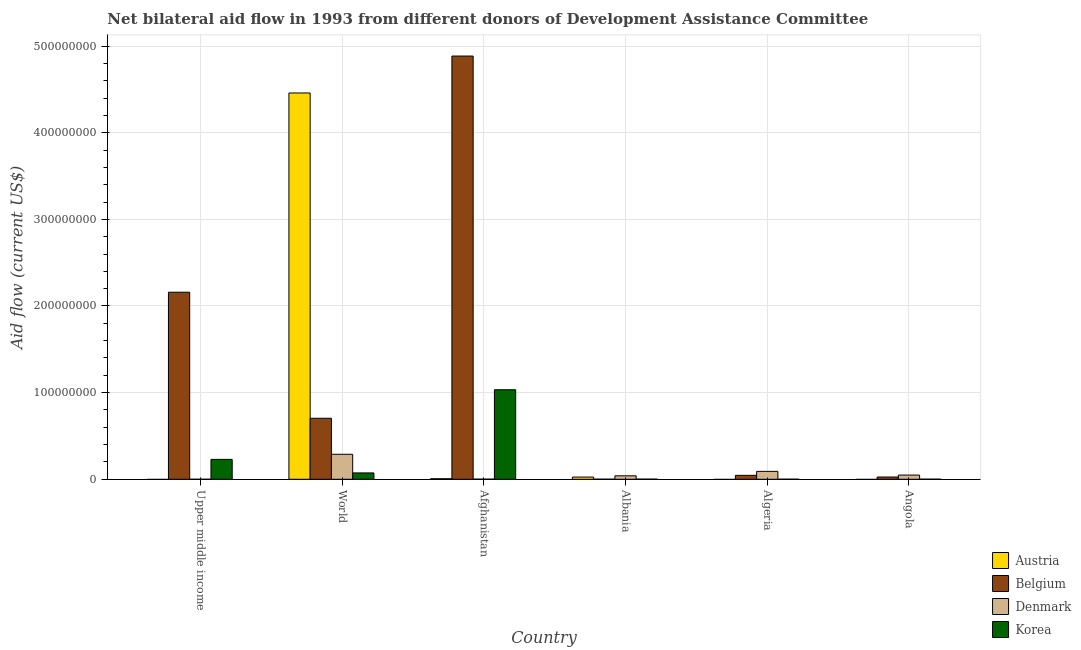How many different coloured bars are there?
Offer a terse response. 4. How many groups of bars are there?
Your answer should be compact. 6. Are the number of bars per tick equal to the number of legend labels?
Make the answer very short. No. Are the number of bars on each tick of the X-axis equal?
Give a very brief answer. No. What is the label of the 3rd group of bars from the left?
Offer a terse response. Afghanistan. In how many cases, is the number of bars for a given country not equal to the number of legend labels?
Offer a terse response. 3. What is the amount of aid given by korea in Albania?
Offer a terse response. 1.40e+05. Across all countries, what is the maximum amount of aid given by austria?
Give a very brief answer. 4.46e+08. Across all countries, what is the minimum amount of aid given by korea?
Ensure brevity in your answer.  7.00e+04. In which country was the amount of aid given by belgium maximum?
Keep it short and to the point. Afghanistan. What is the total amount of aid given by denmark in the graph?
Offer a terse response. 4.69e+07. What is the difference between the amount of aid given by korea in Algeria and that in Angola?
Provide a short and direct response. -4.00e+04. What is the difference between the amount of aid given by belgium in Upper middle income and the amount of aid given by korea in World?
Your response must be concise. 2.09e+08. What is the average amount of aid given by denmark per country?
Offer a very short reply. 7.82e+06. What is the difference between the amount of aid given by denmark and amount of aid given by austria in World?
Ensure brevity in your answer.  -4.17e+08. In how many countries, is the amount of aid given by denmark greater than 160000000 US$?
Your answer should be very brief. 0. What is the ratio of the amount of aid given by belgium in Albania to that in World?
Your answer should be compact. 0. Is the amount of aid given by belgium in Afghanistan less than that in Upper middle income?
Your answer should be very brief. No. What is the difference between the highest and the second highest amount of aid given by belgium?
Provide a short and direct response. 2.73e+08. What is the difference between the highest and the lowest amount of aid given by denmark?
Offer a very short reply. 2.88e+07. In how many countries, is the amount of aid given by austria greater than the average amount of aid given by austria taken over all countries?
Provide a succinct answer. 1. Is it the case that in every country, the sum of the amount of aid given by denmark and amount of aid given by austria is greater than the sum of amount of aid given by korea and amount of aid given by belgium?
Your answer should be compact. Yes. How many bars are there?
Make the answer very short. 21. How many countries are there in the graph?
Provide a succinct answer. 6. Does the graph contain any zero values?
Give a very brief answer. Yes. Does the graph contain grids?
Provide a succinct answer. Yes. Where does the legend appear in the graph?
Provide a succinct answer. Bottom right. How are the legend labels stacked?
Ensure brevity in your answer.  Vertical. What is the title of the graph?
Ensure brevity in your answer.  Net bilateral aid flow in 1993 from different donors of Development Assistance Committee. What is the Aid flow (current US$) in Austria in Upper middle income?
Ensure brevity in your answer.  0. What is the Aid flow (current US$) in Belgium in Upper middle income?
Your answer should be compact. 2.16e+08. What is the Aid flow (current US$) in Korea in Upper middle income?
Ensure brevity in your answer.  2.30e+07. What is the Aid flow (current US$) in Austria in World?
Provide a succinct answer. 4.46e+08. What is the Aid flow (current US$) of Belgium in World?
Offer a terse response. 7.04e+07. What is the Aid flow (current US$) of Denmark in World?
Make the answer very short. 2.88e+07. What is the Aid flow (current US$) in Korea in World?
Make the answer very short. 7.34e+06. What is the Aid flow (current US$) in Austria in Afghanistan?
Your answer should be compact. 6.50e+05. What is the Aid flow (current US$) in Belgium in Afghanistan?
Offer a terse response. 4.88e+08. What is the Aid flow (current US$) of Korea in Afghanistan?
Make the answer very short. 1.03e+08. What is the Aid flow (current US$) of Austria in Albania?
Offer a terse response. 2.54e+06. What is the Aid flow (current US$) in Korea in Albania?
Provide a short and direct response. 1.40e+05. What is the Aid flow (current US$) of Austria in Algeria?
Keep it short and to the point. 0. What is the Aid flow (current US$) of Belgium in Algeria?
Keep it short and to the point. 4.55e+06. What is the Aid flow (current US$) of Denmark in Algeria?
Offer a very short reply. 9.12e+06. What is the Aid flow (current US$) in Belgium in Angola?
Provide a short and direct response. 2.59e+06. What is the Aid flow (current US$) of Denmark in Angola?
Your answer should be very brief. 4.85e+06. What is the Aid flow (current US$) of Korea in Angola?
Your answer should be compact. 1.10e+05. Across all countries, what is the maximum Aid flow (current US$) in Austria?
Provide a short and direct response. 4.46e+08. Across all countries, what is the maximum Aid flow (current US$) in Belgium?
Offer a terse response. 4.88e+08. Across all countries, what is the maximum Aid flow (current US$) in Denmark?
Your response must be concise. 2.88e+07. Across all countries, what is the maximum Aid flow (current US$) in Korea?
Your answer should be compact. 1.03e+08. Across all countries, what is the minimum Aid flow (current US$) of Belgium?
Offer a terse response. 1.00e+05. Across all countries, what is the minimum Aid flow (current US$) of Korea?
Your answer should be very brief. 7.00e+04. What is the total Aid flow (current US$) in Austria in the graph?
Your response must be concise. 4.49e+08. What is the total Aid flow (current US$) in Belgium in the graph?
Offer a very short reply. 7.82e+08. What is the total Aid flow (current US$) of Denmark in the graph?
Your answer should be very brief. 4.69e+07. What is the total Aid flow (current US$) of Korea in the graph?
Ensure brevity in your answer.  1.34e+08. What is the difference between the Aid flow (current US$) in Belgium in Upper middle income and that in World?
Offer a very short reply. 1.45e+08. What is the difference between the Aid flow (current US$) in Denmark in Upper middle income and that in World?
Keep it short and to the point. -2.88e+07. What is the difference between the Aid flow (current US$) in Korea in Upper middle income and that in World?
Your answer should be compact. 1.56e+07. What is the difference between the Aid flow (current US$) in Belgium in Upper middle income and that in Afghanistan?
Make the answer very short. -2.73e+08. What is the difference between the Aid flow (current US$) in Korea in Upper middle income and that in Afghanistan?
Provide a short and direct response. -8.04e+07. What is the difference between the Aid flow (current US$) of Belgium in Upper middle income and that in Albania?
Provide a short and direct response. 2.16e+08. What is the difference between the Aid flow (current US$) of Denmark in Upper middle income and that in Albania?
Your answer should be very brief. -3.99e+06. What is the difference between the Aid flow (current US$) in Korea in Upper middle income and that in Albania?
Your response must be concise. 2.28e+07. What is the difference between the Aid flow (current US$) of Belgium in Upper middle income and that in Algeria?
Give a very brief answer. 2.11e+08. What is the difference between the Aid flow (current US$) of Denmark in Upper middle income and that in Algeria?
Offer a very short reply. -9.11e+06. What is the difference between the Aid flow (current US$) in Korea in Upper middle income and that in Algeria?
Your answer should be very brief. 2.29e+07. What is the difference between the Aid flow (current US$) of Belgium in Upper middle income and that in Angola?
Offer a very short reply. 2.13e+08. What is the difference between the Aid flow (current US$) in Denmark in Upper middle income and that in Angola?
Provide a short and direct response. -4.84e+06. What is the difference between the Aid flow (current US$) of Korea in Upper middle income and that in Angola?
Make the answer very short. 2.28e+07. What is the difference between the Aid flow (current US$) in Austria in World and that in Afghanistan?
Provide a succinct answer. 4.45e+08. What is the difference between the Aid flow (current US$) in Belgium in World and that in Afghanistan?
Provide a short and direct response. -4.18e+08. What is the difference between the Aid flow (current US$) of Denmark in World and that in Afghanistan?
Provide a short and direct response. 2.87e+07. What is the difference between the Aid flow (current US$) in Korea in World and that in Afghanistan?
Keep it short and to the point. -9.60e+07. What is the difference between the Aid flow (current US$) in Austria in World and that in Albania?
Your response must be concise. 4.43e+08. What is the difference between the Aid flow (current US$) of Belgium in World and that in Albania?
Offer a terse response. 7.03e+07. What is the difference between the Aid flow (current US$) of Denmark in World and that in Albania?
Give a very brief answer. 2.48e+07. What is the difference between the Aid flow (current US$) of Korea in World and that in Albania?
Your answer should be very brief. 7.20e+06. What is the difference between the Aid flow (current US$) of Belgium in World and that in Algeria?
Offer a terse response. 6.59e+07. What is the difference between the Aid flow (current US$) in Denmark in World and that in Algeria?
Your answer should be very brief. 1.97e+07. What is the difference between the Aid flow (current US$) of Korea in World and that in Algeria?
Ensure brevity in your answer.  7.27e+06. What is the difference between the Aid flow (current US$) of Belgium in World and that in Angola?
Offer a very short reply. 6.78e+07. What is the difference between the Aid flow (current US$) of Denmark in World and that in Angola?
Your response must be concise. 2.40e+07. What is the difference between the Aid flow (current US$) in Korea in World and that in Angola?
Your response must be concise. 7.23e+06. What is the difference between the Aid flow (current US$) of Austria in Afghanistan and that in Albania?
Offer a very short reply. -1.89e+06. What is the difference between the Aid flow (current US$) of Belgium in Afghanistan and that in Albania?
Ensure brevity in your answer.  4.88e+08. What is the difference between the Aid flow (current US$) in Denmark in Afghanistan and that in Albania?
Your answer should be very brief. -3.89e+06. What is the difference between the Aid flow (current US$) of Korea in Afghanistan and that in Albania?
Your answer should be very brief. 1.03e+08. What is the difference between the Aid flow (current US$) of Belgium in Afghanistan and that in Algeria?
Make the answer very short. 4.84e+08. What is the difference between the Aid flow (current US$) of Denmark in Afghanistan and that in Algeria?
Ensure brevity in your answer.  -9.01e+06. What is the difference between the Aid flow (current US$) of Korea in Afghanistan and that in Algeria?
Provide a short and direct response. 1.03e+08. What is the difference between the Aid flow (current US$) in Belgium in Afghanistan and that in Angola?
Ensure brevity in your answer.  4.86e+08. What is the difference between the Aid flow (current US$) in Denmark in Afghanistan and that in Angola?
Ensure brevity in your answer.  -4.74e+06. What is the difference between the Aid flow (current US$) of Korea in Afghanistan and that in Angola?
Your answer should be compact. 1.03e+08. What is the difference between the Aid flow (current US$) of Belgium in Albania and that in Algeria?
Offer a terse response. -4.45e+06. What is the difference between the Aid flow (current US$) in Denmark in Albania and that in Algeria?
Offer a terse response. -5.12e+06. What is the difference between the Aid flow (current US$) in Korea in Albania and that in Algeria?
Your answer should be very brief. 7.00e+04. What is the difference between the Aid flow (current US$) in Belgium in Albania and that in Angola?
Offer a terse response. -2.49e+06. What is the difference between the Aid flow (current US$) of Denmark in Albania and that in Angola?
Your response must be concise. -8.50e+05. What is the difference between the Aid flow (current US$) in Korea in Albania and that in Angola?
Provide a short and direct response. 3.00e+04. What is the difference between the Aid flow (current US$) in Belgium in Algeria and that in Angola?
Ensure brevity in your answer.  1.96e+06. What is the difference between the Aid flow (current US$) in Denmark in Algeria and that in Angola?
Make the answer very short. 4.27e+06. What is the difference between the Aid flow (current US$) of Korea in Algeria and that in Angola?
Keep it short and to the point. -4.00e+04. What is the difference between the Aid flow (current US$) in Belgium in Upper middle income and the Aid flow (current US$) in Denmark in World?
Keep it short and to the point. 1.87e+08. What is the difference between the Aid flow (current US$) of Belgium in Upper middle income and the Aid flow (current US$) of Korea in World?
Provide a short and direct response. 2.09e+08. What is the difference between the Aid flow (current US$) in Denmark in Upper middle income and the Aid flow (current US$) in Korea in World?
Provide a succinct answer. -7.33e+06. What is the difference between the Aid flow (current US$) in Belgium in Upper middle income and the Aid flow (current US$) in Denmark in Afghanistan?
Offer a very short reply. 2.16e+08. What is the difference between the Aid flow (current US$) of Belgium in Upper middle income and the Aid flow (current US$) of Korea in Afghanistan?
Offer a terse response. 1.13e+08. What is the difference between the Aid flow (current US$) in Denmark in Upper middle income and the Aid flow (current US$) in Korea in Afghanistan?
Give a very brief answer. -1.03e+08. What is the difference between the Aid flow (current US$) in Belgium in Upper middle income and the Aid flow (current US$) in Denmark in Albania?
Offer a very short reply. 2.12e+08. What is the difference between the Aid flow (current US$) in Belgium in Upper middle income and the Aid flow (current US$) in Korea in Albania?
Make the answer very short. 2.16e+08. What is the difference between the Aid flow (current US$) in Denmark in Upper middle income and the Aid flow (current US$) in Korea in Albania?
Keep it short and to the point. -1.30e+05. What is the difference between the Aid flow (current US$) of Belgium in Upper middle income and the Aid flow (current US$) of Denmark in Algeria?
Provide a succinct answer. 2.07e+08. What is the difference between the Aid flow (current US$) of Belgium in Upper middle income and the Aid flow (current US$) of Korea in Algeria?
Keep it short and to the point. 2.16e+08. What is the difference between the Aid flow (current US$) in Denmark in Upper middle income and the Aid flow (current US$) in Korea in Algeria?
Make the answer very short. -6.00e+04. What is the difference between the Aid flow (current US$) of Belgium in Upper middle income and the Aid flow (current US$) of Denmark in Angola?
Offer a terse response. 2.11e+08. What is the difference between the Aid flow (current US$) in Belgium in Upper middle income and the Aid flow (current US$) in Korea in Angola?
Offer a terse response. 2.16e+08. What is the difference between the Aid flow (current US$) in Denmark in Upper middle income and the Aid flow (current US$) in Korea in Angola?
Offer a terse response. -1.00e+05. What is the difference between the Aid flow (current US$) of Austria in World and the Aid flow (current US$) of Belgium in Afghanistan?
Your response must be concise. -4.26e+07. What is the difference between the Aid flow (current US$) of Austria in World and the Aid flow (current US$) of Denmark in Afghanistan?
Your response must be concise. 4.46e+08. What is the difference between the Aid flow (current US$) of Austria in World and the Aid flow (current US$) of Korea in Afghanistan?
Keep it short and to the point. 3.43e+08. What is the difference between the Aid flow (current US$) in Belgium in World and the Aid flow (current US$) in Denmark in Afghanistan?
Your answer should be compact. 7.03e+07. What is the difference between the Aid flow (current US$) of Belgium in World and the Aid flow (current US$) of Korea in Afghanistan?
Keep it short and to the point. -3.29e+07. What is the difference between the Aid flow (current US$) of Denmark in World and the Aid flow (current US$) of Korea in Afghanistan?
Make the answer very short. -7.45e+07. What is the difference between the Aid flow (current US$) of Austria in World and the Aid flow (current US$) of Belgium in Albania?
Give a very brief answer. 4.46e+08. What is the difference between the Aid flow (current US$) in Austria in World and the Aid flow (current US$) in Denmark in Albania?
Provide a succinct answer. 4.42e+08. What is the difference between the Aid flow (current US$) of Austria in World and the Aid flow (current US$) of Korea in Albania?
Your answer should be compact. 4.46e+08. What is the difference between the Aid flow (current US$) in Belgium in World and the Aid flow (current US$) in Denmark in Albania?
Your response must be concise. 6.64e+07. What is the difference between the Aid flow (current US$) in Belgium in World and the Aid flow (current US$) in Korea in Albania?
Keep it short and to the point. 7.03e+07. What is the difference between the Aid flow (current US$) in Denmark in World and the Aid flow (current US$) in Korea in Albania?
Offer a very short reply. 2.87e+07. What is the difference between the Aid flow (current US$) of Austria in World and the Aid flow (current US$) of Belgium in Algeria?
Your answer should be very brief. 4.41e+08. What is the difference between the Aid flow (current US$) of Austria in World and the Aid flow (current US$) of Denmark in Algeria?
Your answer should be very brief. 4.37e+08. What is the difference between the Aid flow (current US$) in Austria in World and the Aid flow (current US$) in Korea in Algeria?
Your answer should be compact. 4.46e+08. What is the difference between the Aid flow (current US$) of Belgium in World and the Aid flow (current US$) of Denmark in Algeria?
Provide a succinct answer. 6.13e+07. What is the difference between the Aid flow (current US$) of Belgium in World and the Aid flow (current US$) of Korea in Algeria?
Ensure brevity in your answer.  7.04e+07. What is the difference between the Aid flow (current US$) in Denmark in World and the Aid flow (current US$) in Korea in Algeria?
Make the answer very short. 2.88e+07. What is the difference between the Aid flow (current US$) in Austria in World and the Aid flow (current US$) in Belgium in Angola?
Your answer should be very brief. 4.43e+08. What is the difference between the Aid flow (current US$) in Austria in World and the Aid flow (current US$) in Denmark in Angola?
Provide a short and direct response. 4.41e+08. What is the difference between the Aid flow (current US$) of Austria in World and the Aid flow (current US$) of Korea in Angola?
Keep it short and to the point. 4.46e+08. What is the difference between the Aid flow (current US$) in Belgium in World and the Aid flow (current US$) in Denmark in Angola?
Offer a very short reply. 6.56e+07. What is the difference between the Aid flow (current US$) in Belgium in World and the Aid flow (current US$) in Korea in Angola?
Give a very brief answer. 7.03e+07. What is the difference between the Aid flow (current US$) of Denmark in World and the Aid flow (current US$) of Korea in Angola?
Your answer should be very brief. 2.87e+07. What is the difference between the Aid flow (current US$) of Austria in Afghanistan and the Aid flow (current US$) of Belgium in Albania?
Your answer should be compact. 5.50e+05. What is the difference between the Aid flow (current US$) of Austria in Afghanistan and the Aid flow (current US$) of Denmark in Albania?
Your answer should be compact. -3.35e+06. What is the difference between the Aid flow (current US$) in Austria in Afghanistan and the Aid flow (current US$) in Korea in Albania?
Ensure brevity in your answer.  5.10e+05. What is the difference between the Aid flow (current US$) in Belgium in Afghanistan and the Aid flow (current US$) in Denmark in Albania?
Offer a terse response. 4.84e+08. What is the difference between the Aid flow (current US$) of Belgium in Afghanistan and the Aid flow (current US$) of Korea in Albania?
Give a very brief answer. 4.88e+08. What is the difference between the Aid flow (current US$) in Denmark in Afghanistan and the Aid flow (current US$) in Korea in Albania?
Your response must be concise. -3.00e+04. What is the difference between the Aid flow (current US$) of Austria in Afghanistan and the Aid flow (current US$) of Belgium in Algeria?
Offer a very short reply. -3.90e+06. What is the difference between the Aid flow (current US$) of Austria in Afghanistan and the Aid flow (current US$) of Denmark in Algeria?
Keep it short and to the point. -8.47e+06. What is the difference between the Aid flow (current US$) in Austria in Afghanistan and the Aid flow (current US$) in Korea in Algeria?
Provide a succinct answer. 5.80e+05. What is the difference between the Aid flow (current US$) of Belgium in Afghanistan and the Aid flow (current US$) of Denmark in Algeria?
Your response must be concise. 4.79e+08. What is the difference between the Aid flow (current US$) of Belgium in Afghanistan and the Aid flow (current US$) of Korea in Algeria?
Provide a succinct answer. 4.88e+08. What is the difference between the Aid flow (current US$) of Denmark in Afghanistan and the Aid flow (current US$) of Korea in Algeria?
Give a very brief answer. 4.00e+04. What is the difference between the Aid flow (current US$) in Austria in Afghanistan and the Aid flow (current US$) in Belgium in Angola?
Offer a very short reply. -1.94e+06. What is the difference between the Aid flow (current US$) of Austria in Afghanistan and the Aid flow (current US$) of Denmark in Angola?
Give a very brief answer. -4.20e+06. What is the difference between the Aid flow (current US$) of Austria in Afghanistan and the Aid flow (current US$) of Korea in Angola?
Provide a succinct answer. 5.40e+05. What is the difference between the Aid flow (current US$) in Belgium in Afghanistan and the Aid flow (current US$) in Denmark in Angola?
Your answer should be compact. 4.84e+08. What is the difference between the Aid flow (current US$) in Belgium in Afghanistan and the Aid flow (current US$) in Korea in Angola?
Give a very brief answer. 4.88e+08. What is the difference between the Aid flow (current US$) in Denmark in Afghanistan and the Aid flow (current US$) in Korea in Angola?
Provide a short and direct response. 0. What is the difference between the Aid flow (current US$) of Austria in Albania and the Aid flow (current US$) of Belgium in Algeria?
Offer a terse response. -2.01e+06. What is the difference between the Aid flow (current US$) of Austria in Albania and the Aid flow (current US$) of Denmark in Algeria?
Offer a terse response. -6.58e+06. What is the difference between the Aid flow (current US$) of Austria in Albania and the Aid flow (current US$) of Korea in Algeria?
Provide a succinct answer. 2.47e+06. What is the difference between the Aid flow (current US$) in Belgium in Albania and the Aid flow (current US$) in Denmark in Algeria?
Ensure brevity in your answer.  -9.02e+06. What is the difference between the Aid flow (current US$) of Denmark in Albania and the Aid flow (current US$) of Korea in Algeria?
Offer a terse response. 3.93e+06. What is the difference between the Aid flow (current US$) of Austria in Albania and the Aid flow (current US$) of Belgium in Angola?
Your answer should be very brief. -5.00e+04. What is the difference between the Aid flow (current US$) of Austria in Albania and the Aid flow (current US$) of Denmark in Angola?
Your answer should be very brief. -2.31e+06. What is the difference between the Aid flow (current US$) of Austria in Albania and the Aid flow (current US$) of Korea in Angola?
Provide a succinct answer. 2.43e+06. What is the difference between the Aid flow (current US$) in Belgium in Albania and the Aid flow (current US$) in Denmark in Angola?
Your answer should be very brief. -4.75e+06. What is the difference between the Aid flow (current US$) of Belgium in Albania and the Aid flow (current US$) of Korea in Angola?
Ensure brevity in your answer.  -10000. What is the difference between the Aid flow (current US$) in Denmark in Albania and the Aid flow (current US$) in Korea in Angola?
Give a very brief answer. 3.89e+06. What is the difference between the Aid flow (current US$) of Belgium in Algeria and the Aid flow (current US$) of Korea in Angola?
Ensure brevity in your answer.  4.44e+06. What is the difference between the Aid flow (current US$) in Denmark in Algeria and the Aid flow (current US$) in Korea in Angola?
Your answer should be compact. 9.01e+06. What is the average Aid flow (current US$) in Austria per country?
Make the answer very short. 7.48e+07. What is the average Aid flow (current US$) of Belgium per country?
Offer a very short reply. 1.30e+08. What is the average Aid flow (current US$) in Denmark per country?
Offer a very short reply. 7.82e+06. What is the average Aid flow (current US$) of Korea per country?
Make the answer very short. 2.23e+07. What is the difference between the Aid flow (current US$) of Belgium and Aid flow (current US$) of Denmark in Upper middle income?
Make the answer very short. 2.16e+08. What is the difference between the Aid flow (current US$) of Belgium and Aid flow (current US$) of Korea in Upper middle income?
Give a very brief answer. 1.93e+08. What is the difference between the Aid flow (current US$) in Denmark and Aid flow (current US$) in Korea in Upper middle income?
Give a very brief answer. -2.29e+07. What is the difference between the Aid flow (current US$) in Austria and Aid flow (current US$) in Belgium in World?
Offer a terse response. 3.75e+08. What is the difference between the Aid flow (current US$) of Austria and Aid flow (current US$) of Denmark in World?
Offer a terse response. 4.17e+08. What is the difference between the Aid flow (current US$) in Austria and Aid flow (current US$) in Korea in World?
Give a very brief answer. 4.39e+08. What is the difference between the Aid flow (current US$) in Belgium and Aid flow (current US$) in Denmark in World?
Provide a short and direct response. 4.16e+07. What is the difference between the Aid flow (current US$) of Belgium and Aid flow (current US$) of Korea in World?
Your answer should be very brief. 6.31e+07. What is the difference between the Aid flow (current US$) in Denmark and Aid flow (current US$) in Korea in World?
Provide a short and direct response. 2.15e+07. What is the difference between the Aid flow (current US$) of Austria and Aid flow (current US$) of Belgium in Afghanistan?
Your response must be concise. -4.88e+08. What is the difference between the Aid flow (current US$) of Austria and Aid flow (current US$) of Denmark in Afghanistan?
Your answer should be very brief. 5.40e+05. What is the difference between the Aid flow (current US$) of Austria and Aid flow (current US$) of Korea in Afghanistan?
Provide a succinct answer. -1.03e+08. What is the difference between the Aid flow (current US$) of Belgium and Aid flow (current US$) of Denmark in Afghanistan?
Your answer should be very brief. 4.88e+08. What is the difference between the Aid flow (current US$) in Belgium and Aid flow (current US$) in Korea in Afghanistan?
Your answer should be very brief. 3.85e+08. What is the difference between the Aid flow (current US$) in Denmark and Aid flow (current US$) in Korea in Afghanistan?
Provide a succinct answer. -1.03e+08. What is the difference between the Aid flow (current US$) in Austria and Aid flow (current US$) in Belgium in Albania?
Your answer should be very brief. 2.44e+06. What is the difference between the Aid flow (current US$) in Austria and Aid flow (current US$) in Denmark in Albania?
Keep it short and to the point. -1.46e+06. What is the difference between the Aid flow (current US$) of Austria and Aid flow (current US$) of Korea in Albania?
Your response must be concise. 2.40e+06. What is the difference between the Aid flow (current US$) of Belgium and Aid flow (current US$) of Denmark in Albania?
Ensure brevity in your answer.  -3.90e+06. What is the difference between the Aid flow (current US$) of Belgium and Aid flow (current US$) of Korea in Albania?
Keep it short and to the point. -4.00e+04. What is the difference between the Aid flow (current US$) in Denmark and Aid flow (current US$) in Korea in Albania?
Give a very brief answer. 3.86e+06. What is the difference between the Aid flow (current US$) of Belgium and Aid flow (current US$) of Denmark in Algeria?
Give a very brief answer. -4.57e+06. What is the difference between the Aid flow (current US$) in Belgium and Aid flow (current US$) in Korea in Algeria?
Your response must be concise. 4.48e+06. What is the difference between the Aid flow (current US$) in Denmark and Aid flow (current US$) in Korea in Algeria?
Offer a very short reply. 9.05e+06. What is the difference between the Aid flow (current US$) in Belgium and Aid flow (current US$) in Denmark in Angola?
Make the answer very short. -2.26e+06. What is the difference between the Aid flow (current US$) in Belgium and Aid flow (current US$) in Korea in Angola?
Provide a succinct answer. 2.48e+06. What is the difference between the Aid flow (current US$) in Denmark and Aid flow (current US$) in Korea in Angola?
Your answer should be compact. 4.74e+06. What is the ratio of the Aid flow (current US$) of Belgium in Upper middle income to that in World?
Make the answer very short. 3.07. What is the ratio of the Aid flow (current US$) of Korea in Upper middle income to that in World?
Give a very brief answer. 3.13. What is the ratio of the Aid flow (current US$) of Belgium in Upper middle income to that in Afghanistan?
Keep it short and to the point. 0.44. What is the ratio of the Aid flow (current US$) in Denmark in Upper middle income to that in Afghanistan?
Give a very brief answer. 0.09. What is the ratio of the Aid flow (current US$) of Korea in Upper middle income to that in Afghanistan?
Offer a very short reply. 0.22. What is the ratio of the Aid flow (current US$) of Belgium in Upper middle income to that in Albania?
Your answer should be compact. 2159.1. What is the ratio of the Aid flow (current US$) of Denmark in Upper middle income to that in Albania?
Ensure brevity in your answer.  0. What is the ratio of the Aid flow (current US$) in Korea in Upper middle income to that in Albania?
Your answer should be very brief. 163.93. What is the ratio of the Aid flow (current US$) of Belgium in Upper middle income to that in Algeria?
Make the answer very short. 47.45. What is the ratio of the Aid flow (current US$) in Denmark in Upper middle income to that in Algeria?
Keep it short and to the point. 0. What is the ratio of the Aid flow (current US$) of Korea in Upper middle income to that in Algeria?
Give a very brief answer. 327.86. What is the ratio of the Aid flow (current US$) in Belgium in Upper middle income to that in Angola?
Make the answer very short. 83.36. What is the ratio of the Aid flow (current US$) of Denmark in Upper middle income to that in Angola?
Ensure brevity in your answer.  0. What is the ratio of the Aid flow (current US$) of Korea in Upper middle income to that in Angola?
Give a very brief answer. 208.64. What is the ratio of the Aid flow (current US$) of Austria in World to that in Afghanistan?
Make the answer very short. 685.92. What is the ratio of the Aid flow (current US$) of Belgium in World to that in Afghanistan?
Your answer should be very brief. 0.14. What is the ratio of the Aid flow (current US$) in Denmark in World to that in Afghanistan?
Your answer should be compact. 262.27. What is the ratio of the Aid flow (current US$) of Korea in World to that in Afghanistan?
Give a very brief answer. 0.07. What is the ratio of the Aid flow (current US$) in Austria in World to that in Albania?
Keep it short and to the point. 175.53. What is the ratio of the Aid flow (current US$) of Belgium in World to that in Albania?
Offer a very short reply. 704.2. What is the ratio of the Aid flow (current US$) in Denmark in World to that in Albania?
Provide a succinct answer. 7.21. What is the ratio of the Aid flow (current US$) in Korea in World to that in Albania?
Your answer should be compact. 52.43. What is the ratio of the Aid flow (current US$) in Belgium in World to that in Algeria?
Provide a succinct answer. 15.48. What is the ratio of the Aid flow (current US$) of Denmark in World to that in Algeria?
Your response must be concise. 3.16. What is the ratio of the Aid flow (current US$) in Korea in World to that in Algeria?
Offer a terse response. 104.86. What is the ratio of the Aid flow (current US$) of Belgium in World to that in Angola?
Provide a short and direct response. 27.19. What is the ratio of the Aid flow (current US$) of Denmark in World to that in Angola?
Your answer should be compact. 5.95. What is the ratio of the Aid flow (current US$) in Korea in World to that in Angola?
Make the answer very short. 66.73. What is the ratio of the Aid flow (current US$) of Austria in Afghanistan to that in Albania?
Ensure brevity in your answer.  0.26. What is the ratio of the Aid flow (current US$) in Belgium in Afghanistan to that in Albania?
Your answer should be compact. 4884.9. What is the ratio of the Aid flow (current US$) in Denmark in Afghanistan to that in Albania?
Your response must be concise. 0.03. What is the ratio of the Aid flow (current US$) of Korea in Afghanistan to that in Albania?
Provide a short and direct response. 738.07. What is the ratio of the Aid flow (current US$) in Belgium in Afghanistan to that in Algeria?
Your answer should be very brief. 107.36. What is the ratio of the Aid flow (current US$) of Denmark in Afghanistan to that in Algeria?
Give a very brief answer. 0.01. What is the ratio of the Aid flow (current US$) in Korea in Afghanistan to that in Algeria?
Make the answer very short. 1476.14. What is the ratio of the Aid flow (current US$) of Belgium in Afghanistan to that in Angola?
Provide a short and direct response. 188.61. What is the ratio of the Aid flow (current US$) in Denmark in Afghanistan to that in Angola?
Provide a succinct answer. 0.02. What is the ratio of the Aid flow (current US$) of Korea in Afghanistan to that in Angola?
Give a very brief answer. 939.36. What is the ratio of the Aid flow (current US$) of Belgium in Albania to that in Algeria?
Provide a short and direct response. 0.02. What is the ratio of the Aid flow (current US$) of Denmark in Albania to that in Algeria?
Keep it short and to the point. 0.44. What is the ratio of the Aid flow (current US$) in Korea in Albania to that in Algeria?
Provide a short and direct response. 2. What is the ratio of the Aid flow (current US$) in Belgium in Albania to that in Angola?
Offer a very short reply. 0.04. What is the ratio of the Aid flow (current US$) of Denmark in Albania to that in Angola?
Provide a short and direct response. 0.82. What is the ratio of the Aid flow (current US$) of Korea in Albania to that in Angola?
Keep it short and to the point. 1.27. What is the ratio of the Aid flow (current US$) of Belgium in Algeria to that in Angola?
Offer a very short reply. 1.76. What is the ratio of the Aid flow (current US$) of Denmark in Algeria to that in Angola?
Offer a terse response. 1.88. What is the ratio of the Aid flow (current US$) in Korea in Algeria to that in Angola?
Ensure brevity in your answer.  0.64. What is the difference between the highest and the second highest Aid flow (current US$) of Austria?
Offer a very short reply. 4.43e+08. What is the difference between the highest and the second highest Aid flow (current US$) of Belgium?
Your response must be concise. 2.73e+08. What is the difference between the highest and the second highest Aid flow (current US$) of Denmark?
Your answer should be very brief. 1.97e+07. What is the difference between the highest and the second highest Aid flow (current US$) in Korea?
Your response must be concise. 8.04e+07. What is the difference between the highest and the lowest Aid flow (current US$) of Austria?
Provide a succinct answer. 4.46e+08. What is the difference between the highest and the lowest Aid flow (current US$) in Belgium?
Ensure brevity in your answer.  4.88e+08. What is the difference between the highest and the lowest Aid flow (current US$) of Denmark?
Your response must be concise. 2.88e+07. What is the difference between the highest and the lowest Aid flow (current US$) in Korea?
Provide a succinct answer. 1.03e+08. 